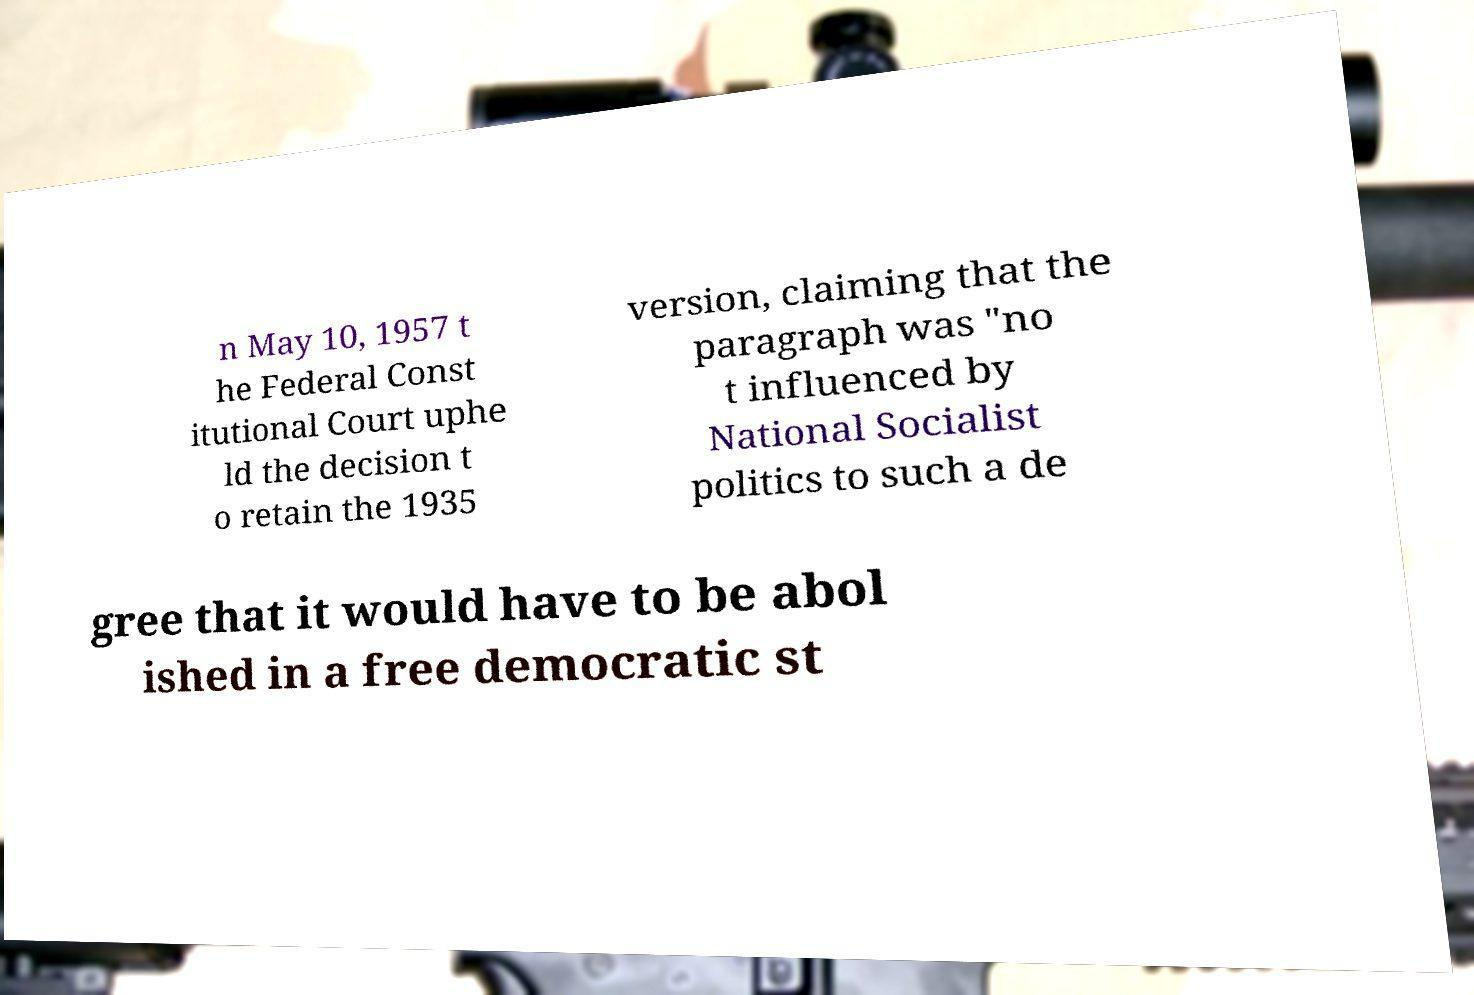There's text embedded in this image that I need extracted. Can you transcribe it verbatim? n May 10, 1957 t he Federal Const itutional Court uphe ld the decision t o retain the 1935 version, claiming that the paragraph was "no t influenced by National Socialist politics to such a de gree that it would have to be abol ished in a free democratic st 